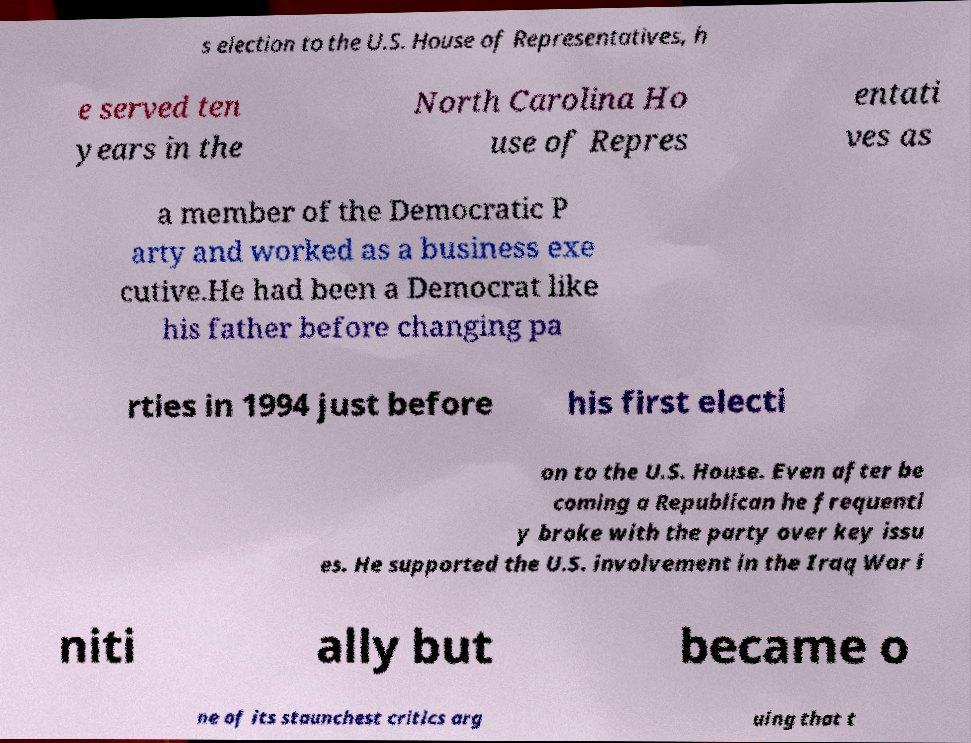Can you read and provide the text displayed in the image?This photo seems to have some interesting text. Can you extract and type it out for me? s election to the U.S. House of Representatives, h e served ten years in the North Carolina Ho use of Repres entati ves as a member of the Democratic P arty and worked as a business exe cutive.He had been a Democrat like his father before changing pa rties in 1994 just before his first electi on to the U.S. House. Even after be coming a Republican he frequentl y broke with the party over key issu es. He supported the U.S. involvement in the Iraq War i niti ally but became o ne of its staunchest critics arg uing that t 